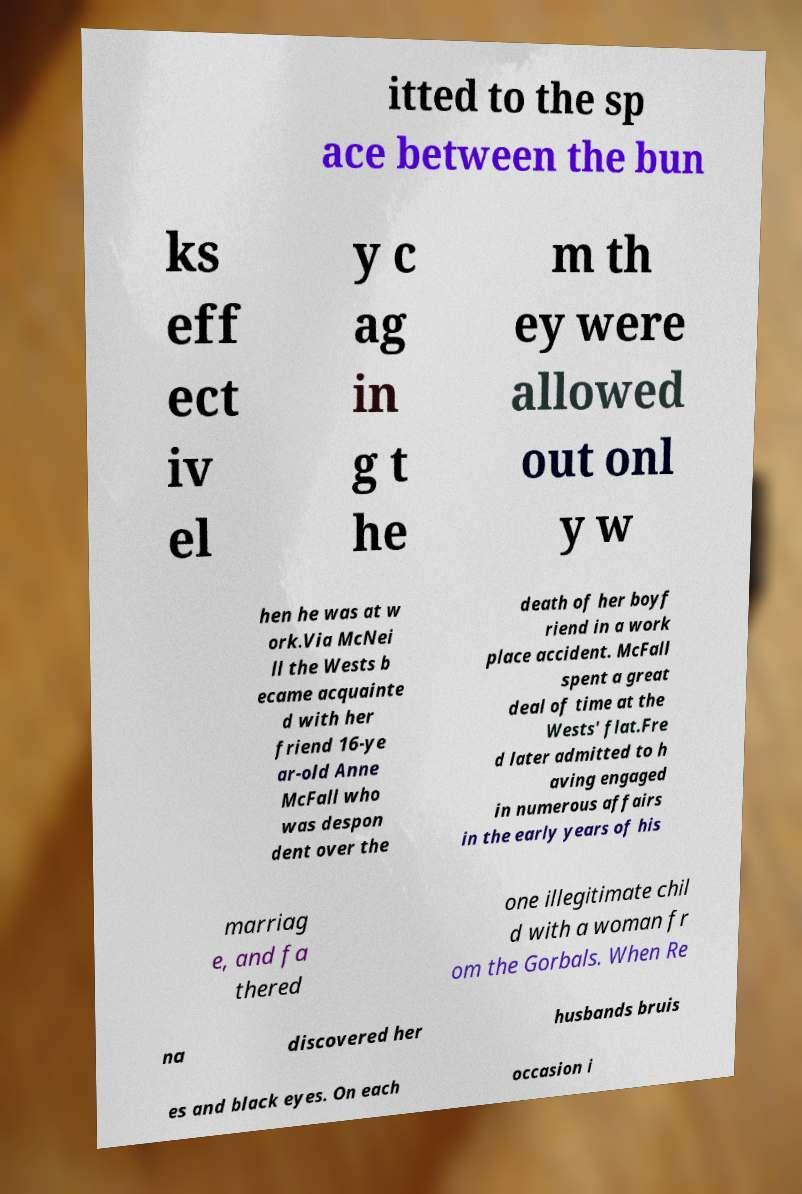Could you extract and type out the text from this image? itted to the sp ace between the bun ks eff ect iv el y c ag in g t he m th ey were allowed out onl y w hen he was at w ork.Via McNei ll the Wests b ecame acquainte d with her friend 16-ye ar-old Anne McFall who was despon dent over the death of her boyf riend in a work place accident. McFall spent a great deal of time at the Wests' flat.Fre d later admitted to h aving engaged in numerous affairs in the early years of his marriag e, and fa thered one illegitimate chil d with a woman fr om the Gorbals. When Re na discovered her husbands bruis es and black eyes. On each occasion i 